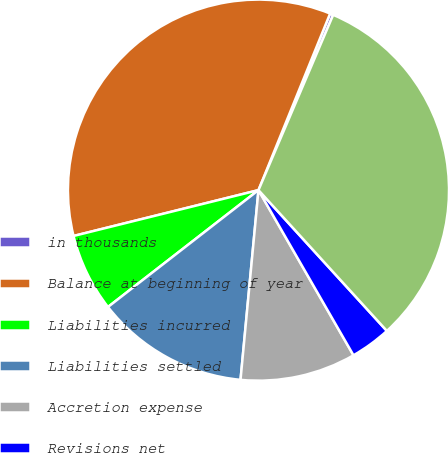Convert chart. <chart><loc_0><loc_0><loc_500><loc_500><pie_chart><fcel>in thousands<fcel>Balance at beginning of year<fcel>Liabilities incurred<fcel>Liabilities settled<fcel>Accretion expense<fcel>Revisions net<fcel>Balance at end of year<nl><fcel>0.28%<fcel>35.0%<fcel>6.64%<fcel>12.99%<fcel>9.81%<fcel>3.46%<fcel>31.82%<nl></chart> 